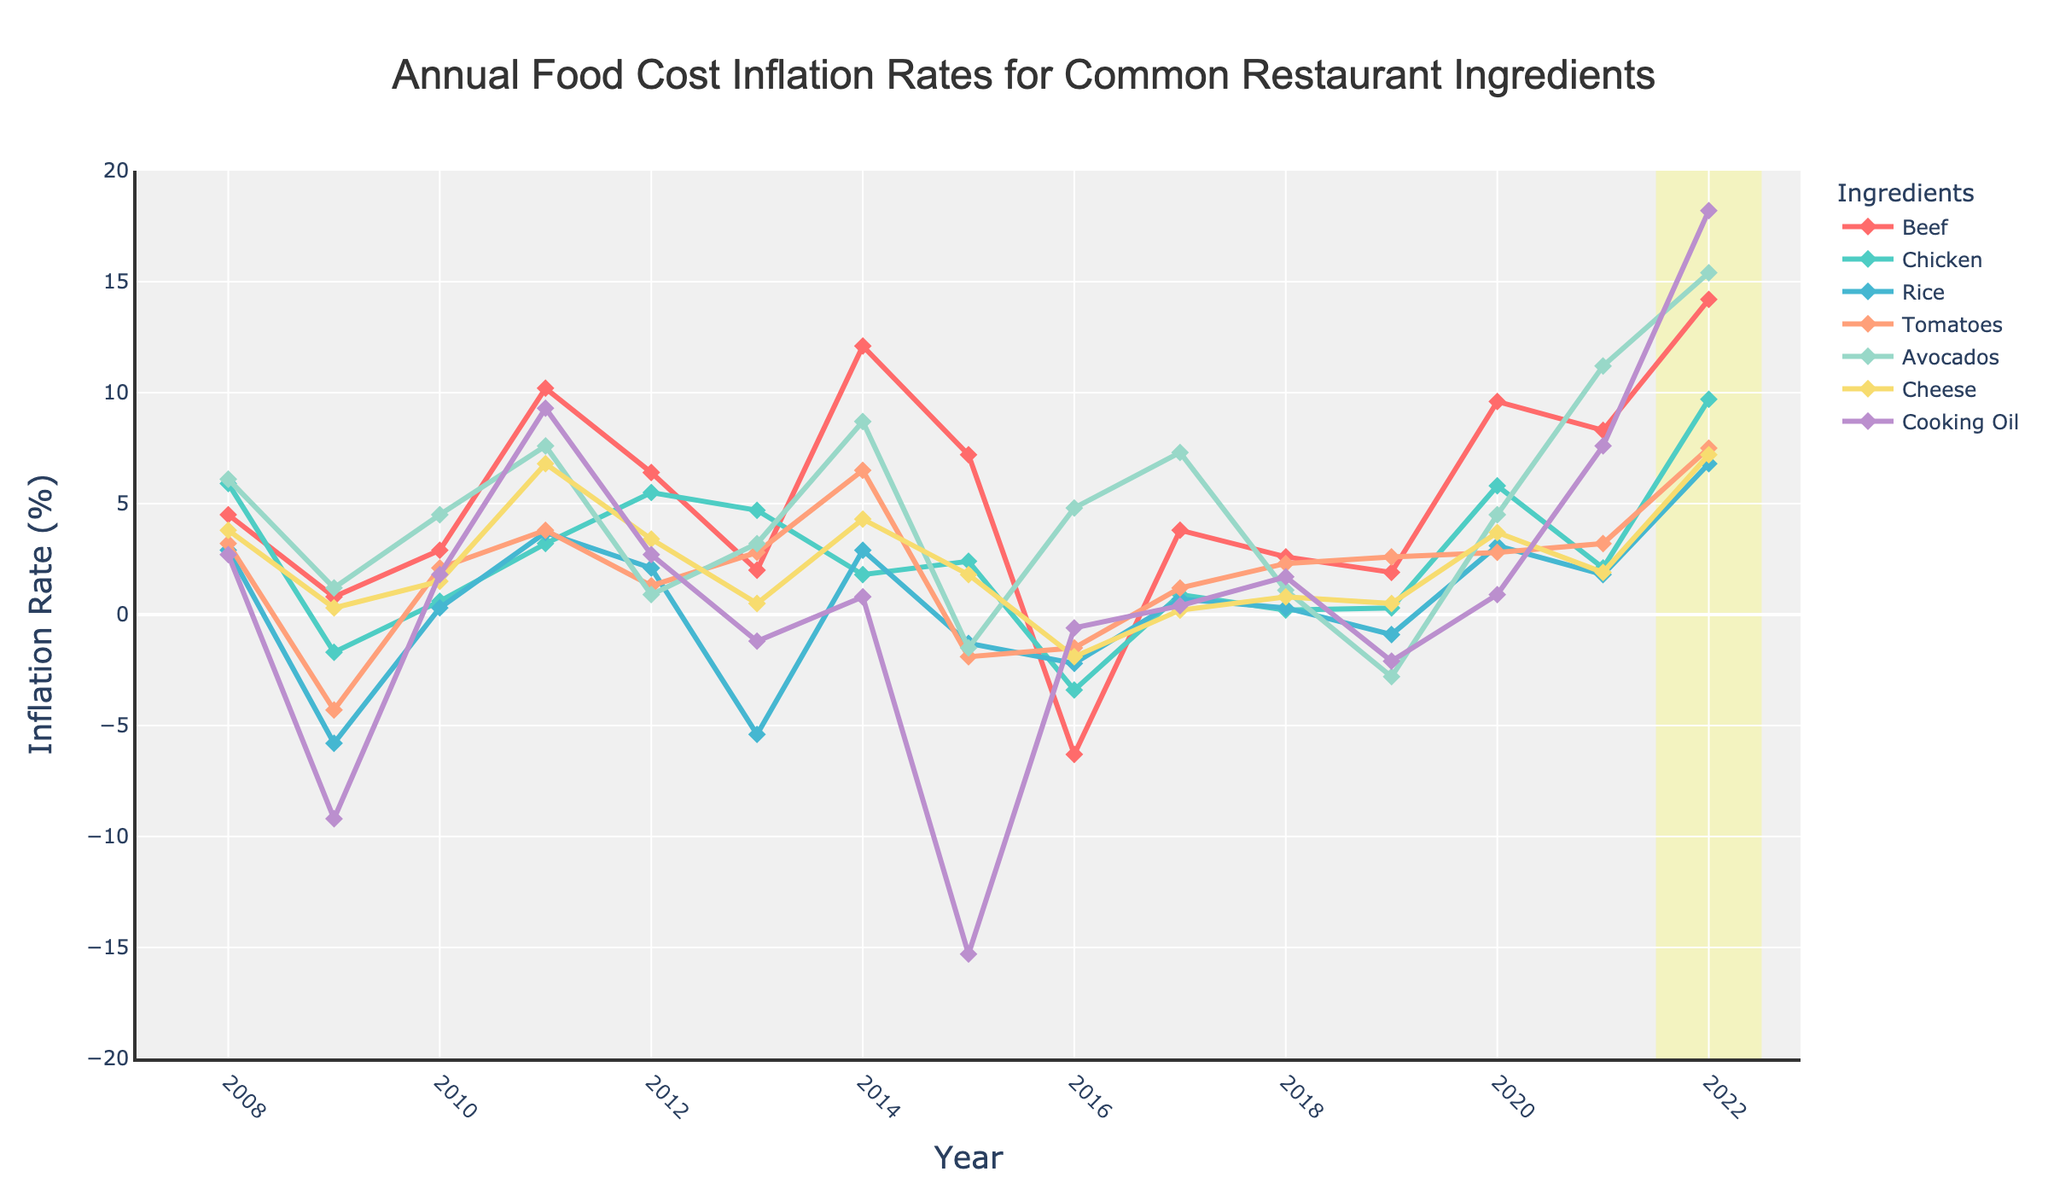What was the inflation rate for Avocados in 2022? Locate the Avocados line and check the inflation rate value at the year "2022."
Answer: 15.4 Which ingredient experienced the highest inflation rate in 2014? Compare the inflation rate values for all ingredients for the year "2014" to identify the highest one.
Answer: Beef During which year did Cooking Oil experience its highest inflation rate and what was the rate? Trace the Cooking Oil line to find the peak value over the years and identify its corresponding year.
Answer: 2022, 18.2 Which ingredients had negative inflation rates in 2016? Identify the lines below the zero mark on the y-axis for the year "2016."
Answer: Beef, Chicken, Rice, Tomatoes, Cheese How did the inflation rates for Beef and Chicken compare in 2011? Locate the values for Beef and Chicken for the year "2011" and compare them.
Answer: Beef (10.2) was higher than Chicken (3.2) What is the overall trend in the inflation rate for Cheese from 2008 to 2022? Observe the Cheese line from 2008 to 2022 to identify whether it's generally increasing, decreasing, or fluctuating.
Answer: Fluctuating with an upward spike towards the end Calculate the average inflation rate for Rice over the first 5 years shown in the chart. Sum the inflation rates for Rice from 2008 to 2012 and divide by 5.
Answer: (2.9 - 5.8 + 0.3 + 3.7 + 2.1) / 5 = 0.64 Between which two consecutive years did Avocados experience the biggest change in inflation rate? Calculate the year-to-year changes in inflation rate for Avocados and identify the largest change.
Answer: 2021 to 2022 Which ingredient had the most consistent inflation rate over the 15 years period? Examine the fluctuations or stability of each line over the years.
Answer: Cooking Oil How does the inflation rate for beef in 2011 compare to 2022? Locate the values for Beef for the years "2011" and "2022" and compare them.
Answer: 2022 rate (14.2) is higher than 2011 (10.2) 